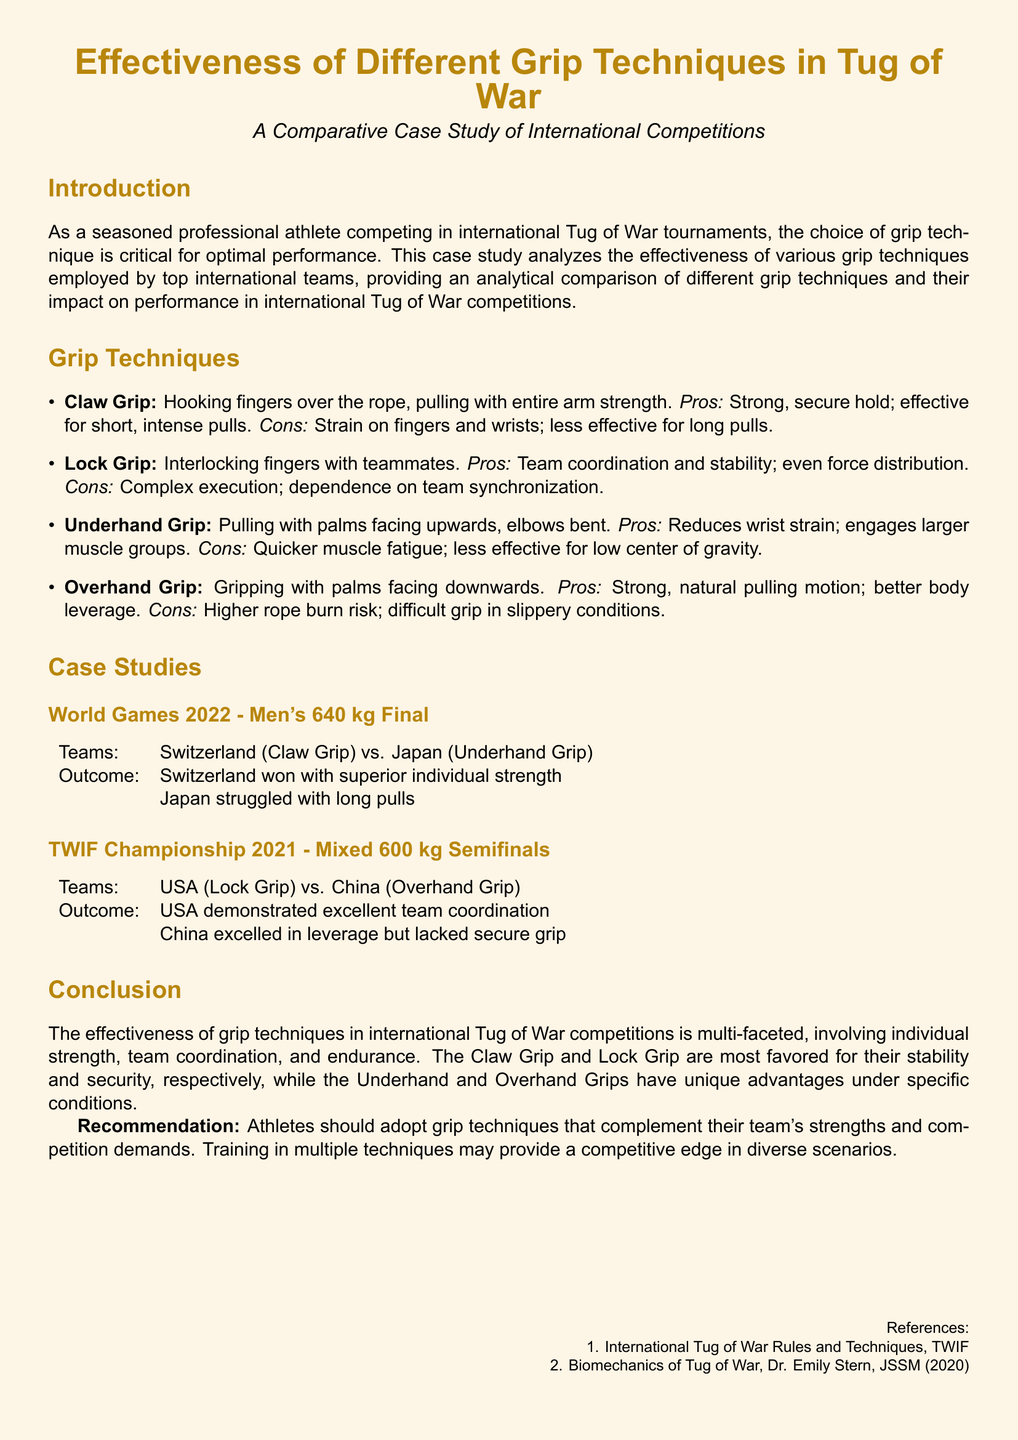What is the main focus of the case study? The main focus of the case study is the effectiveness of various grip techniques employed by international Tug of War teams.
Answer: effectiveness of various grip techniques What are the four grip techniques discussed? The document lists four grip techniques: Claw Grip, Lock Grip, Underhand Grip, and Overhand Grip.
Answer: Claw Grip, Lock Grip, Underhand Grip, Overhand Grip Which grip technique did Switzerland use in the World Games 2022 final? Switzerland used the Claw Grip technique in the World Games 2022 final.
Answer: Claw Grip What was a noted disadvantage of the Underhand Grip? The Underhand Grip has quicker muscle fatigue as a noted disadvantage.
Answer: quicker muscle fatigue Which grip technique exhibited excellent team coordination in the TWIF Championship 2021? The USA team demonstrated excellent team coordination using the Lock Grip in the TWIF Championship 2021.
Answer: Lock Grip What was the outcome for Japan during the World Games 2022 final? Japan struggled with long pulls and lost the final to Switzerland.
Answer: struggled with long pulls What is the recommendation given to athletes regarding grip techniques? Athletes are recommended to adopt grip techniques that complement their team's strengths and competition demands.
Answer: adopt grip techniques that complement their team's strengths What color is used for the document's background? The document's background is a shade of beige.
Answer: beige 